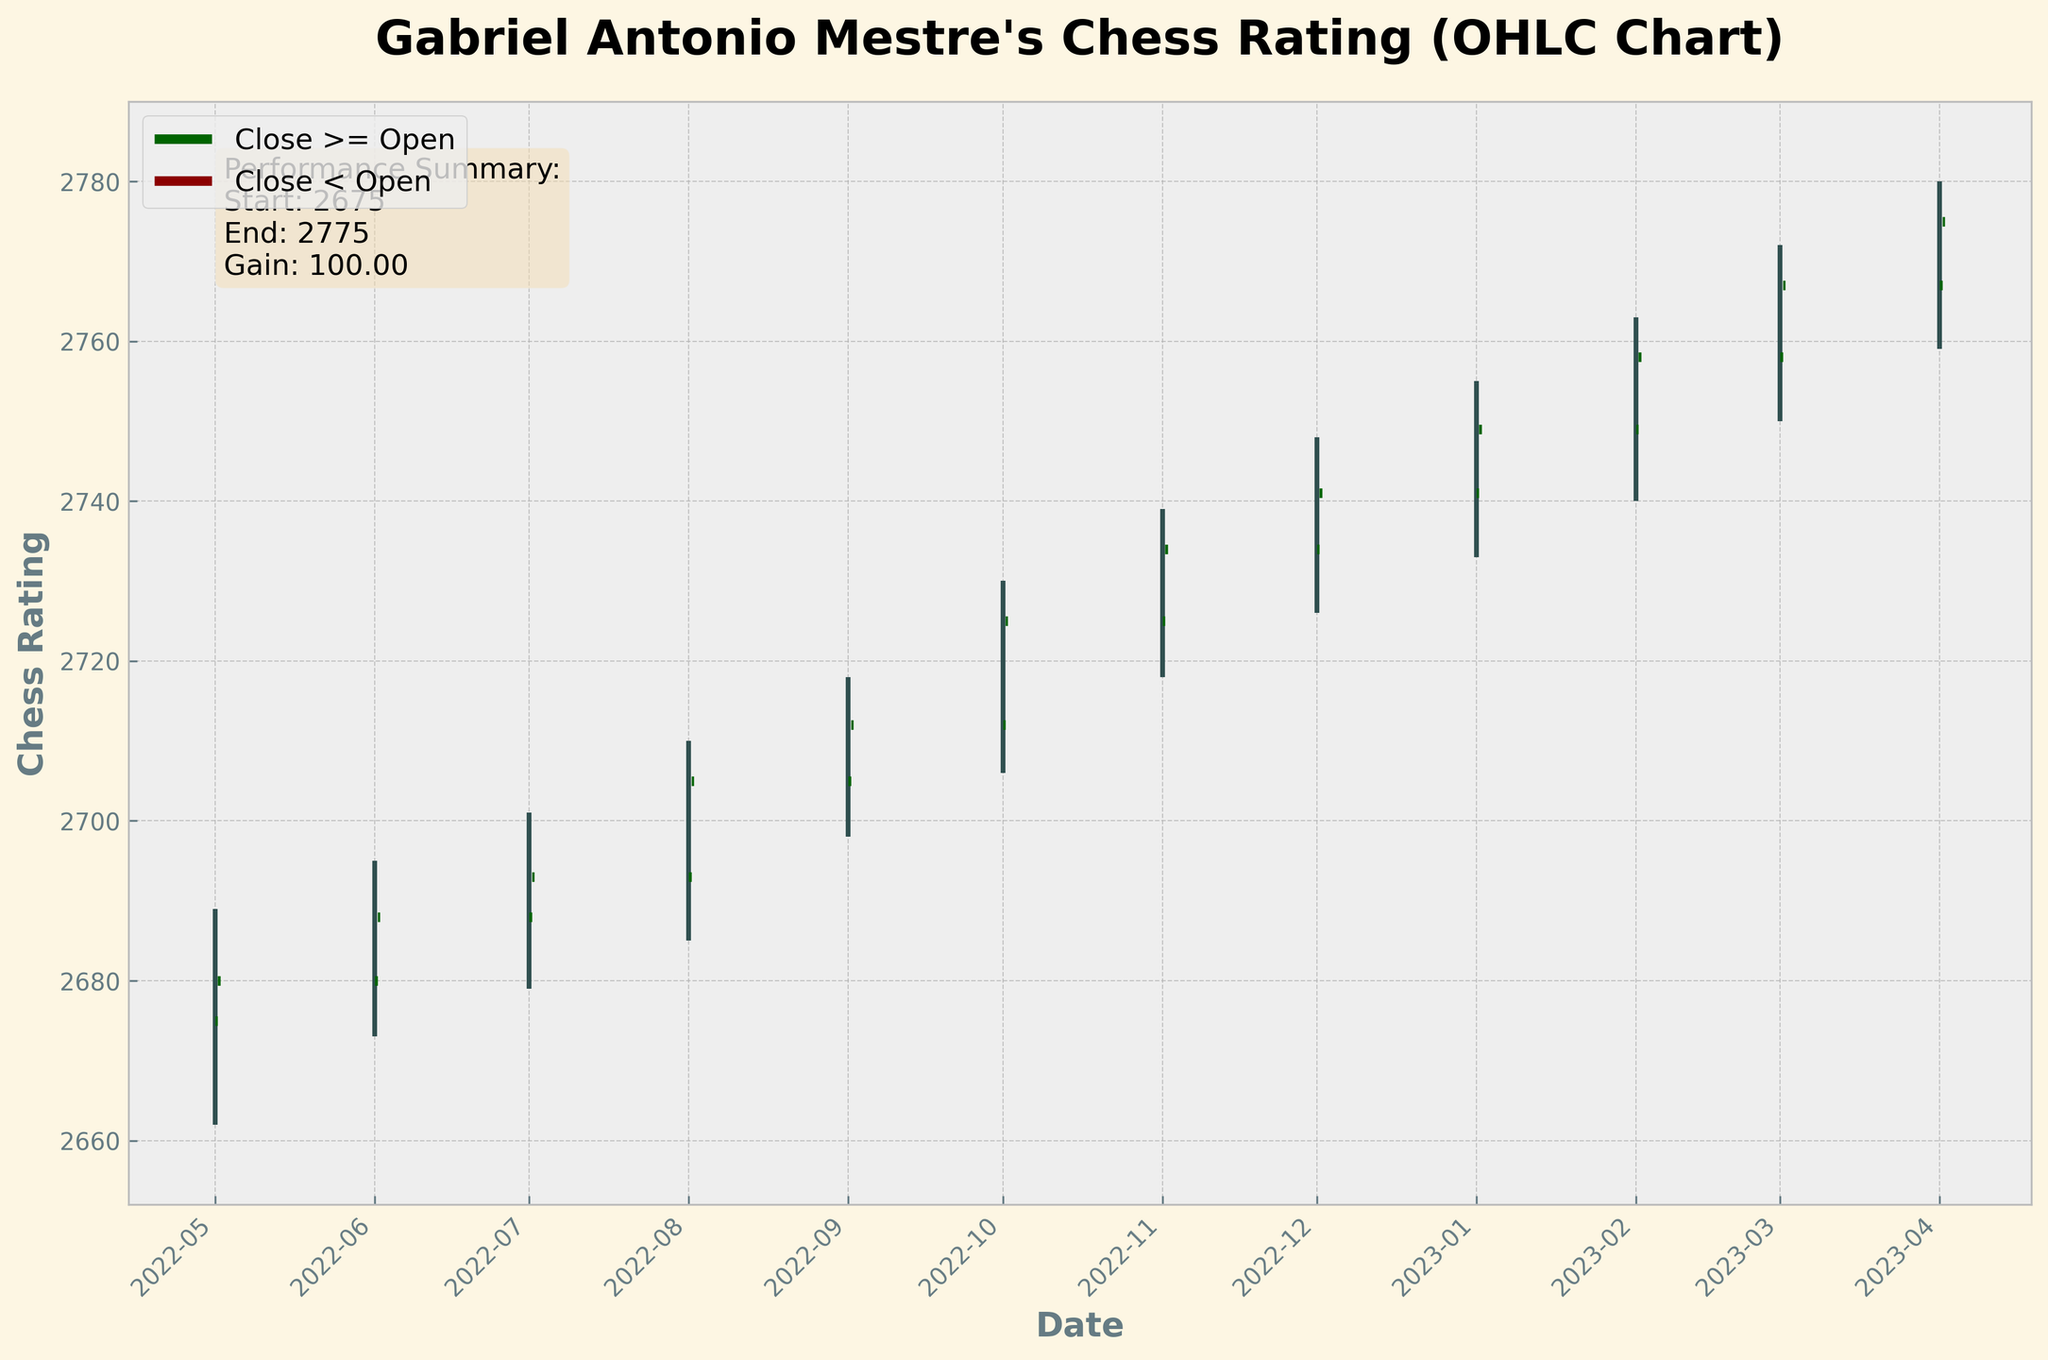What is the title of the chart? The title of the chart is usually displayed at the top and provides a brief description of what the chart is about. In this case, the title is "Gabriel Antonio Mestre's Chess Rating (OHLC Chart)".
Answer: Gabriel Antonio Mestre's Chess Rating (OHLC Chart) How many months are covered in the chart? The number of months can be determined by counting the data points represented on the x-axis. Each vertical line represents one month. From May 2022 to April 2023, there are 12 months.
Answer: 12 What colors are used to indicate when the close price is greater than or equal to the open price, and when it is less? The color indicating that the close price is greater than or equal to the open price is typically green (a symbol of gain), while the color indicating that the close price is less than the open price is red (a symbol of loss).
Answer: Green and Red Which month had the highest 'High' value and what was it? Look for the tallest vertical line or the data point where the top of the line is the highest on the y-axis. In this chart, March 2023 had the highest 'High' value at 2780.
Answer: March 2023, 2780 What is the summary of Gabriel's performance over the year? The summary is provided in the text box within the chart. According to the text box, the performance summary shows the start and end chess ratings, and the total gain over the year. Specifically, the start is 2675, the end is 2775, and the gain is 100 points.
Answer: Start: 2675, End: 2775, Gain: 100 Which months show a closing value higher than its opening value? To determine this, observe the color of the horizontal lines indicating the open and close prices. Green lines indicate months where the closing value is higher than the opening value. These months are: May 2022, June 2022, July 2022, August 2022, September 2022, October 2022, November 2022, December 2022, January 2023, February 2023, March 2023, and April 2023; i.e., all 12 months in this chart.
Answer: All 12 months What was the lowest 'Low' value in the chart and in which month did it occur? Look for the shortest vertical line or the data point where the bottom of the line is the lowest on the y-axis. The lowest 'Low' value is 2662 which occurred in May 2022.
Answer: 2662, May 2022 Which month showed the largest difference between the 'High' and 'Low' values? To find out, calculate the difference between the 'High' and 'Low' values for each month, and compare these differences. The largest such difference is observed in March 2023 (2772 - 2750 = 22).
Answer: March 2023 What is the average 'Close' value over the past year? To calculate the average closing value, sum up all the 'Close' values and divide by the number of months. The sum is \( 2680 + 2688 + 2693 + 2705 + 2712 + 2725 + 2734 + 2741 + 2749 + 2758 + 2767 + 2775 = 32827 \). Dividing this by 12 gives the average closing value of \( \frac{32827}{12} \approx 2735.58 \).
Answer: 2735.58 In which month did Gabriel achieve his first 'Close' value above 2700? Observe the close prices for each month sequentially. The first 'Close' value above 2700 is in August 2022, where the 'Close' is 2705.
Answer: August 2022 